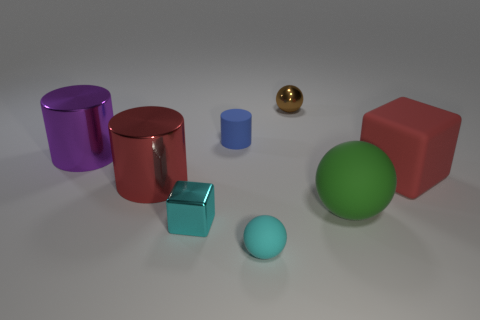Which objects in the image are spheres? In the visual provided, there are two spherical objects. One is a large green matte sphere, and the second is a small gold shiny sphere. 